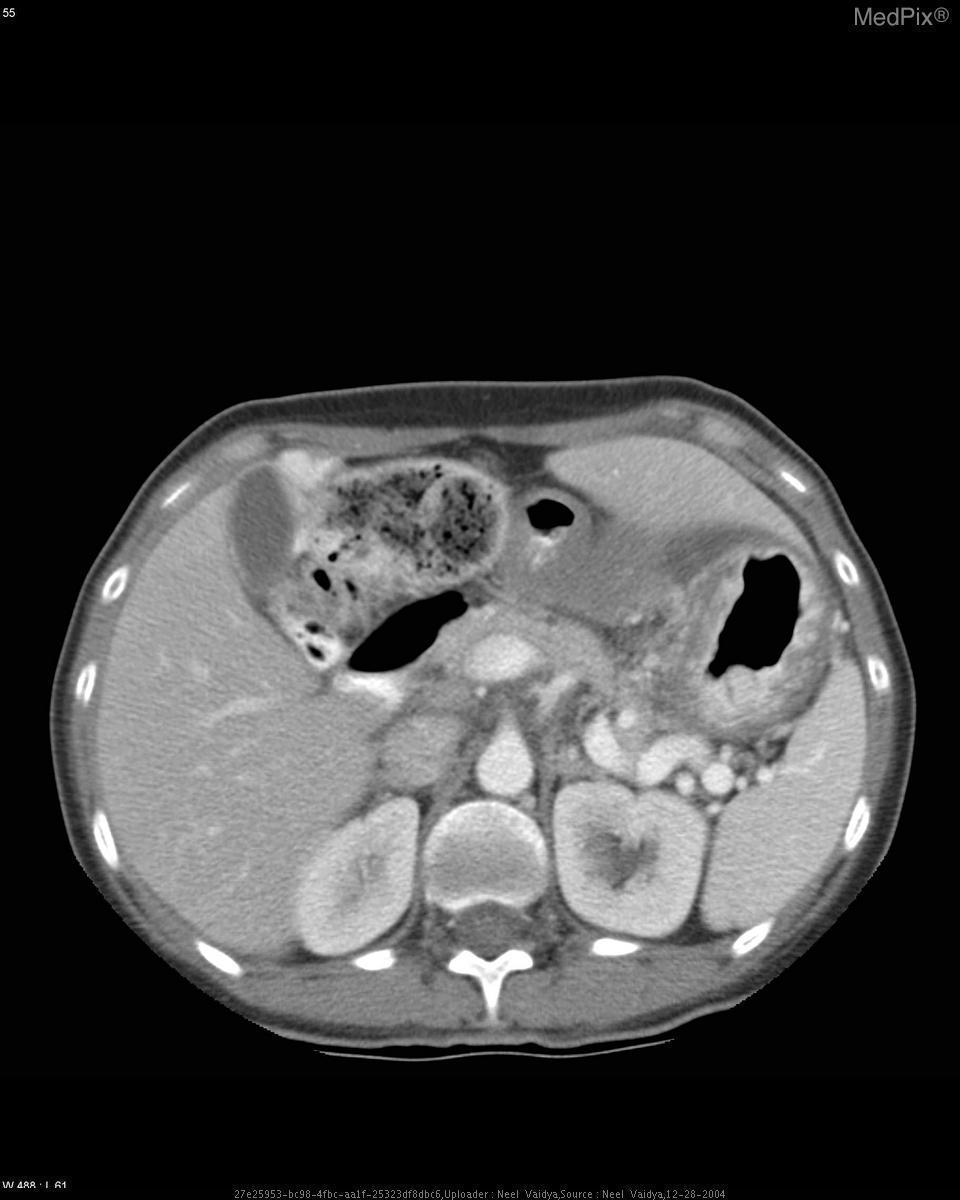Are there more than 5 enlarged (>1 cm) lymph nodes around the stomach
Keep it brief. Yes. Are there >5 lymph nodes located near the stomach?
Short answer required. Yes. Was the patient given iv contrast?
Be succinct. Yes. Is there contrast in the patient's vasculature?
Be succinct. Yes. Is the gallbladder large in size?
Concise answer only. No. Is the gallbladder distended?
Concise answer only. No. Is the stomach thickening regular and uniform or ragged/asymmetrical?
Concise answer only. Asymmetric. Is the stomach wall thickening symmetric or asymmetric?
Answer briefly. Asymmetric. 